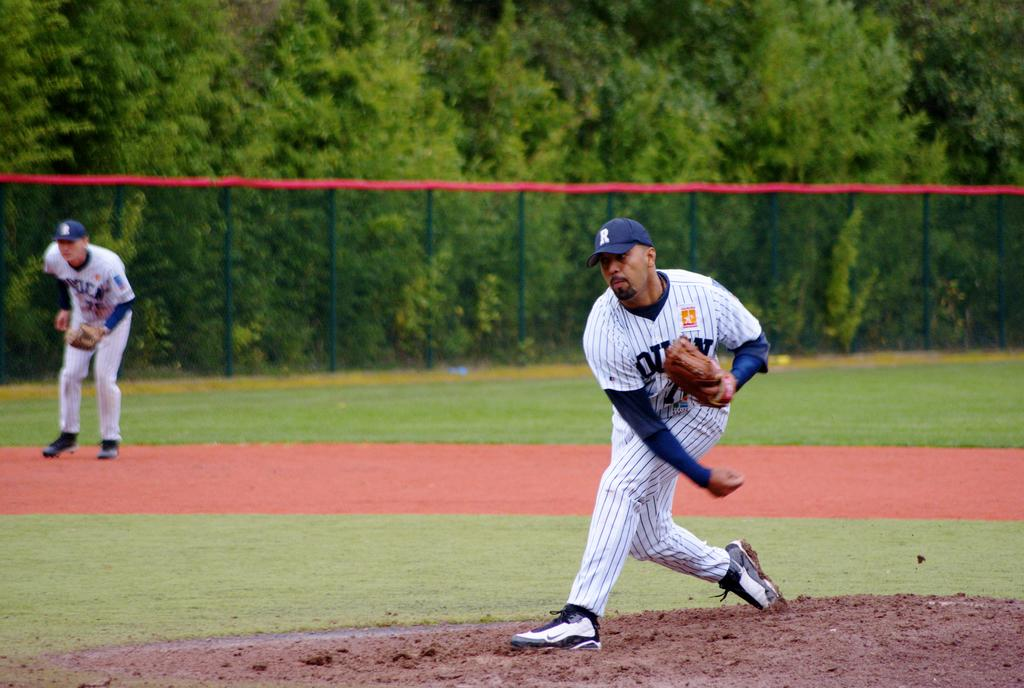<image>
Write a terse but informative summary of the picture. Baseball player wearing a cap with the letter R on it. 